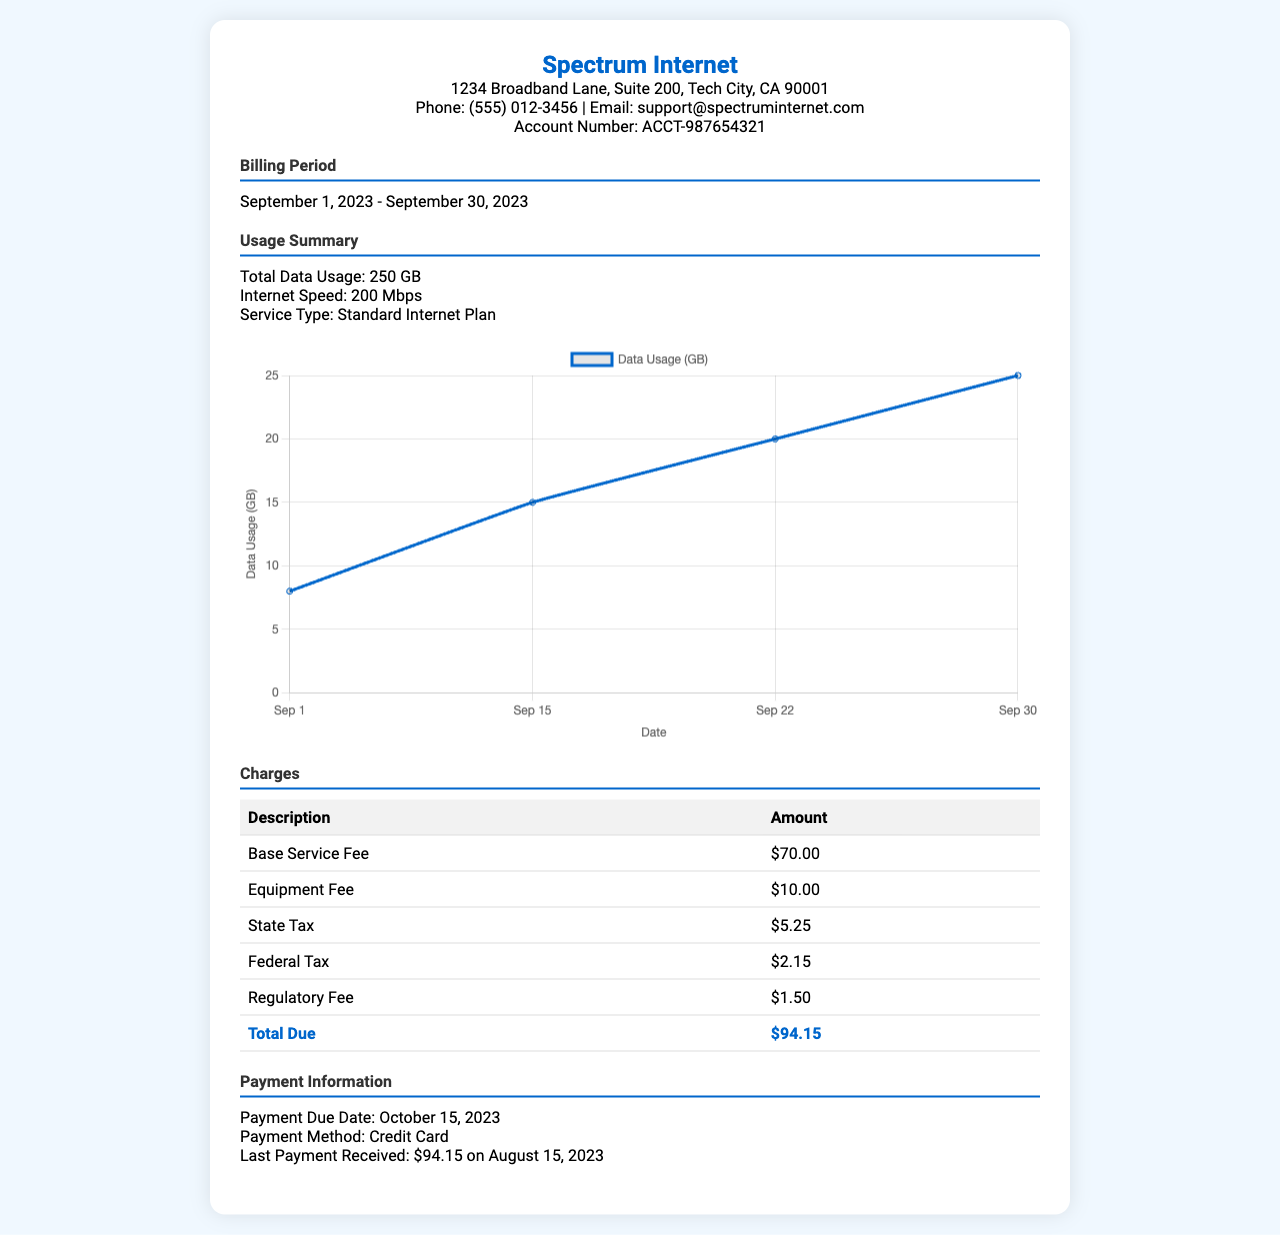what is the billing period? The billing period is stated in the document as the duration for which the services are billed.
Answer: September 1, 2023 - September 30, 2023 what is the total data usage? The total data usage is a specific measurement of data consumed during the billing period.
Answer: 250 GB what is the account number? The account number is necessary for identifying the customer within the service provider's database.
Answer: ACCT-987654321 how much is the base service fee? The base service fee is listed as a charge for the internet service.
Answer: $70.00 what is the total amount due? The total amount due is the final calculation of all charges and taxes for the service period.
Answer: $94.15 what payment method is used? The payment method indicates how the customer intends to pay their bill and is detailed in the payment section.
Answer: Credit Card what is the state tax amount? The state tax amount is a specific charge applied to the bill as part of the overall costs.
Answer: $5.25 when is the payment due date? The payment due date is crucial for the customer to know when they need to complete their payment to avoid penalties.
Answer: October 15, 2023 how much was the last payment received? The last payment received provides context on previous transactions and payment history for the account.
Answer: $94.15 